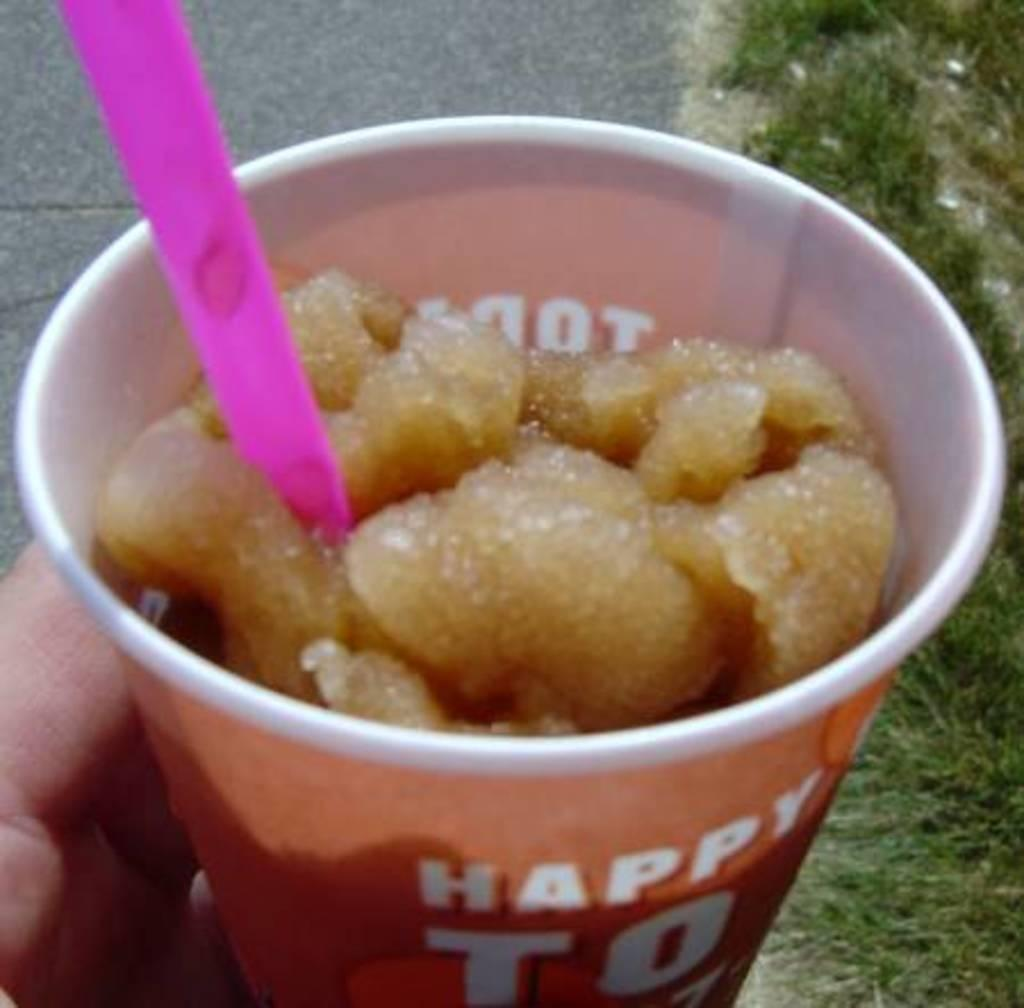What part of a person can be seen in the image? A person's hand is visible in the image. What is the person holding in their hand? The person is holding a cup. What is inside the cup? The cup contains food. What utensil is present in the cup? There is a spoon in the cup. What type of vegetation is on the right side of the image? There is grass on the right side of the image. Where is the grass located? The grass is on the land. What can be seen on the left side of the image? There is a road on the left side of the image. What type of guitar is the person playing in the image? There is no guitar present in the image; the person is holding a cup. What is the name of the person in the image? The image does not show the person's face or provide any information about their name. 